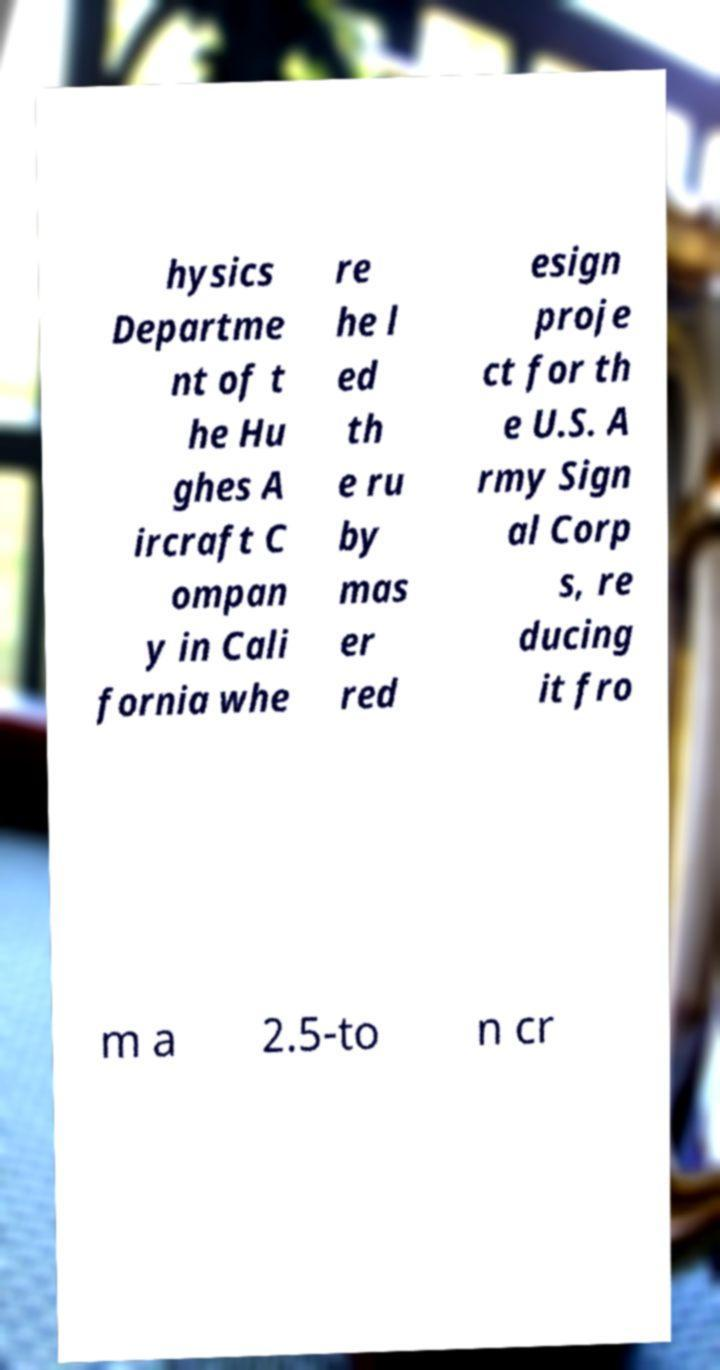Please read and relay the text visible in this image. What does it say? hysics Departme nt of t he Hu ghes A ircraft C ompan y in Cali fornia whe re he l ed th e ru by mas er red esign proje ct for th e U.S. A rmy Sign al Corp s, re ducing it fro m a 2.5-to n cr 